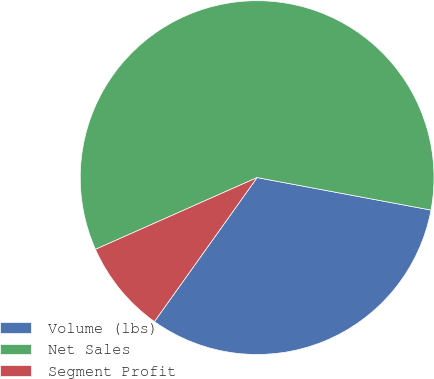Convert chart to OTSL. <chart><loc_0><loc_0><loc_500><loc_500><pie_chart><fcel>Volume (lbs)<fcel>Net Sales<fcel>Segment Profit<nl><fcel>31.92%<fcel>59.59%<fcel>8.49%<nl></chart> 